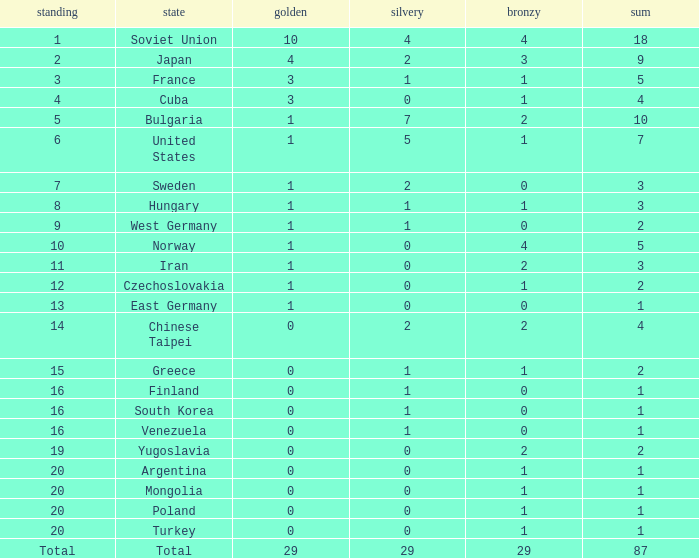How many gold medals does the 14th rank have in total? 0.0. 